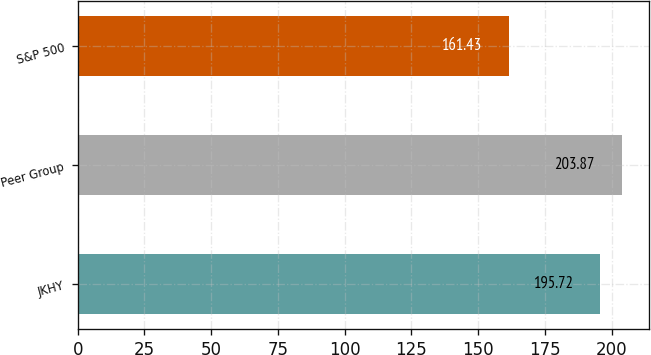<chart> <loc_0><loc_0><loc_500><loc_500><bar_chart><fcel>JKHY<fcel>Peer Group<fcel>S&P 500<nl><fcel>195.72<fcel>203.87<fcel>161.43<nl></chart> 